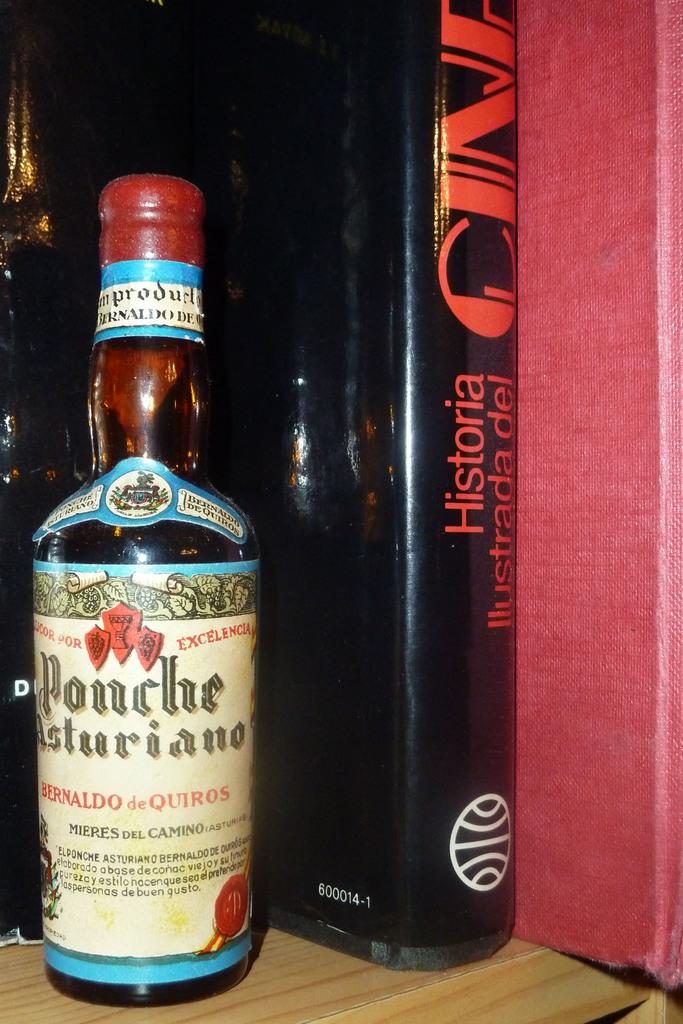What is this whiskey called?
Offer a terse response. Ponche. What number is on the back of the book?
Ensure brevity in your answer.  600014-1. 